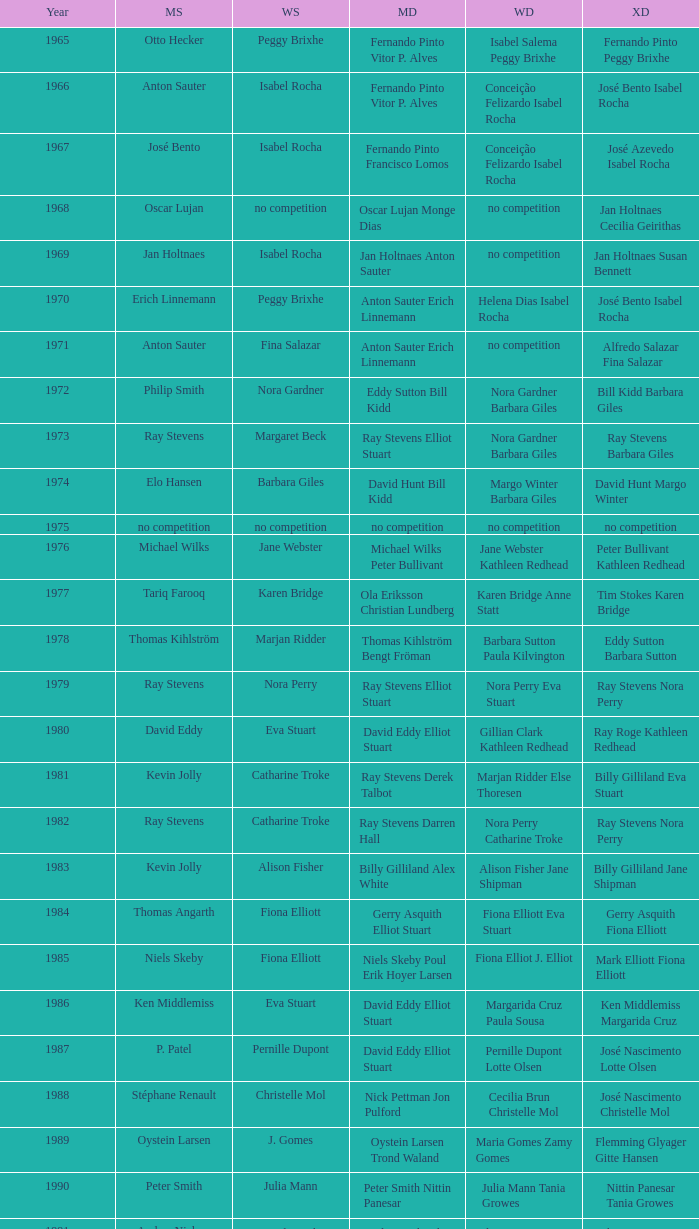What is the average year with alfredo salazar fina salazar in mixed doubles? 1971.0. 